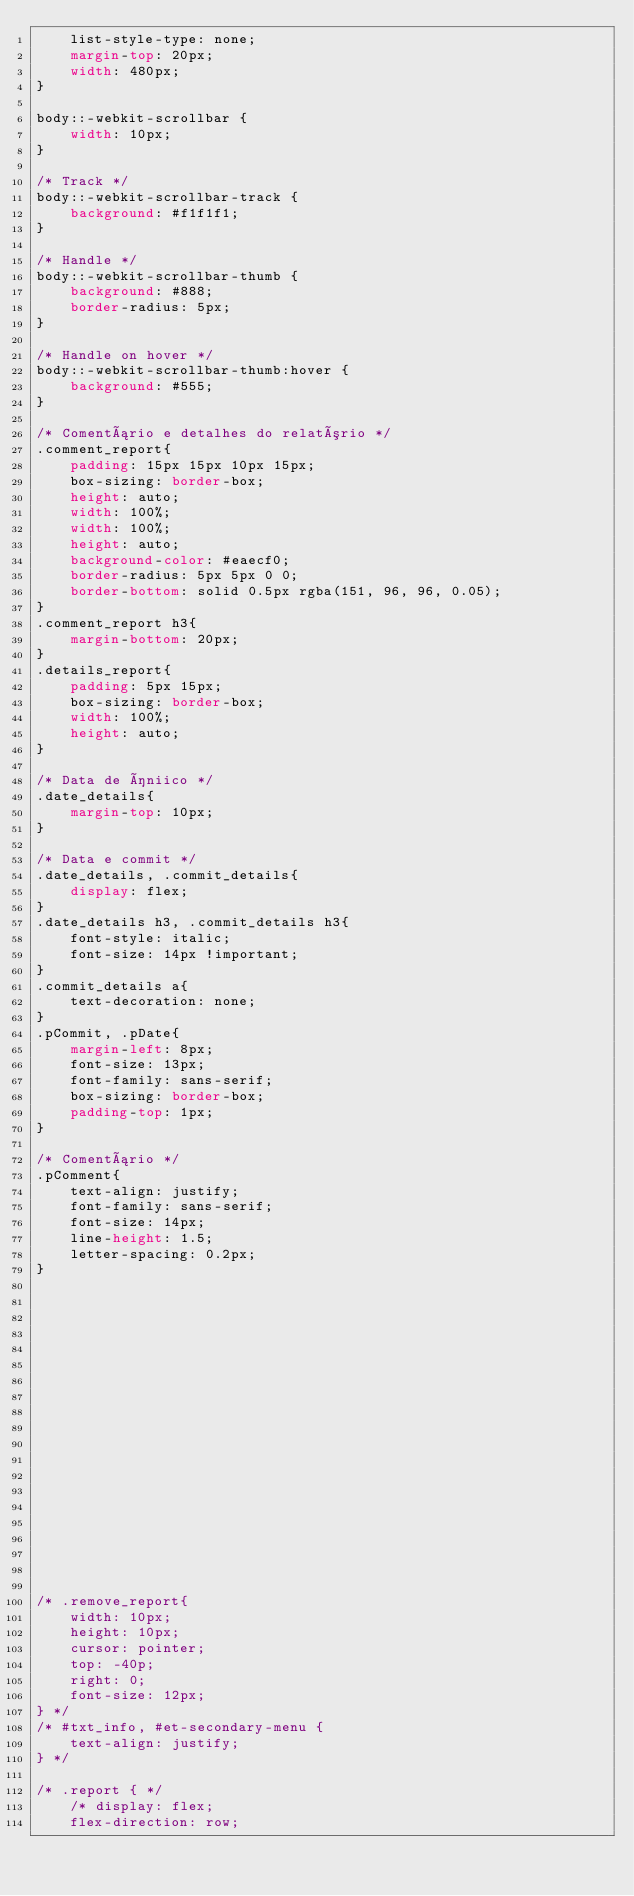Convert code to text. <code><loc_0><loc_0><loc_500><loc_500><_CSS_>    list-style-type: none;
    margin-top: 20px;
    width: 480px;
}

body::-webkit-scrollbar {
    width: 10px;
}
  
/* Track */
body::-webkit-scrollbar-track {
    background: #f1f1f1;
}

/* Handle */
body::-webkit-scrollbar-thumb {
    background: #888;
    border-radius: 5px;
}

/* Handle on hover */
body::-webkit-scrollbar-thumb:hover {
    background: #555;
}

/* Comentário e detalhes do relatório */
.comment_report{
    padding: 15px 15px 10px 15px;
    box-sizing: border-box;
    height: auto;
    width: 100%;
    width: 100%;
    height: auto;
    background-color: #eaecf0;
    border-radius: 5px 5px 0 0; 
    border-bottom: solid 0.5px rgba(151, 96, 96, 0.05);
}
.comment_report h3{
    margin-bottom: 20px;
}
.details_report{
    padding: 5px 15px;
    box-sizing: border-box;
    width: 100%;
    height: auto;
}

/* Data de íniico */
.date_details{
    margin-top: 10px;
}

/* Data e commit */
.date_details, .commit_details{
    display: flex;
}
.date_details h3, .commit_details h3{
    font-style: italic;
    font-size: 14px !important;
}
.commit_details a{
    text-decoration: none;
}
.pCommit, .pDate{
    margin-left: 8px;
    font-size: 13px;
    font-family: sans-serif;
    box-sizing: border-box;
    padding-top: 1px;
}

/* Comentário */
.pComment{
    text-align: justify;
    font-family: sans-serif;
    font-size: 14px;
    line-height: 1.5;
    letter-spacing: 0.2px;
}




















/* .remove_report{
    width: 10px;
    height: 10px;
    cursor: pointer;
    top: -40p;
    right: 0;
    font-size: 12px;
} */
/* #txt_info, #et-secondary-menu {
    text-align: justify;
} */

/* .report { */
    /* display: flex;
    flex-direction: row;</code> 